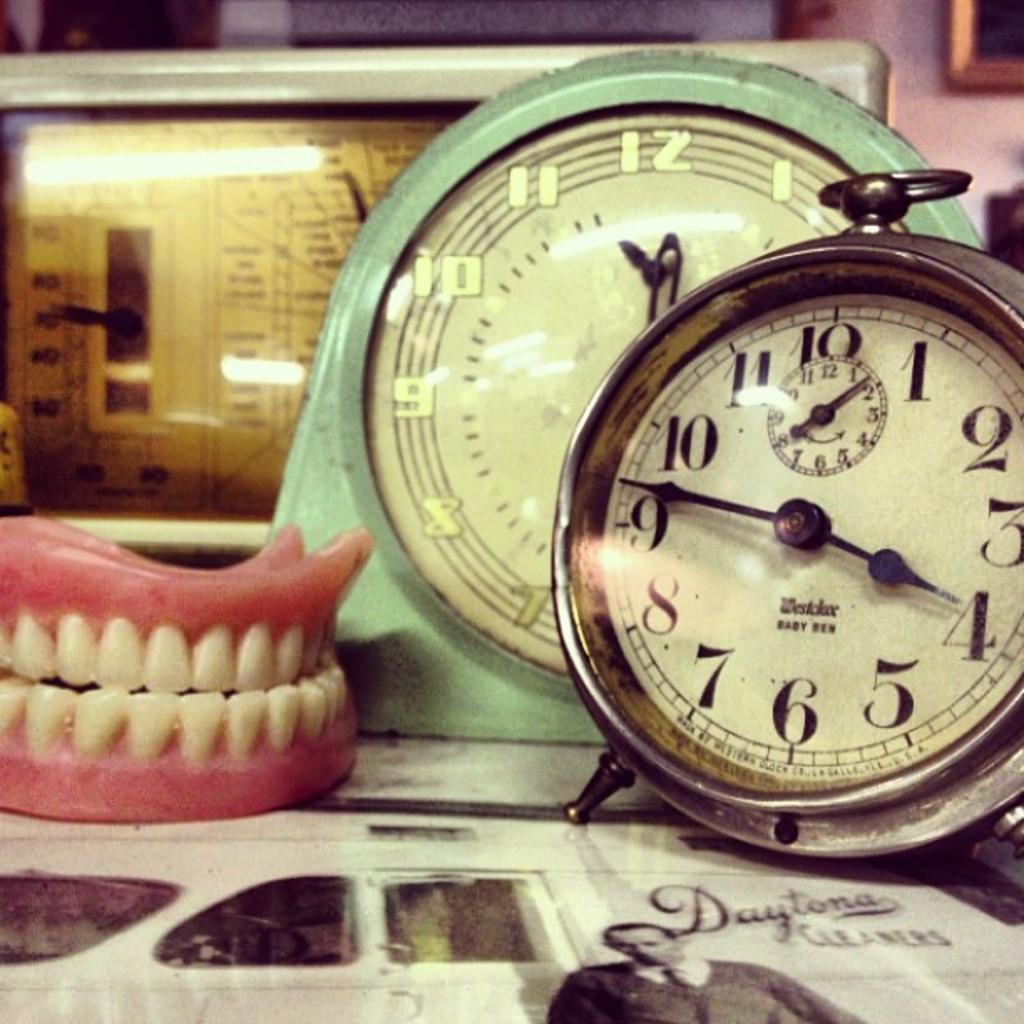What is the brand of cleaners?
Keep it short and to the point. Daytona. What time is it on the clock?
Your response must be concise. 3:47. 